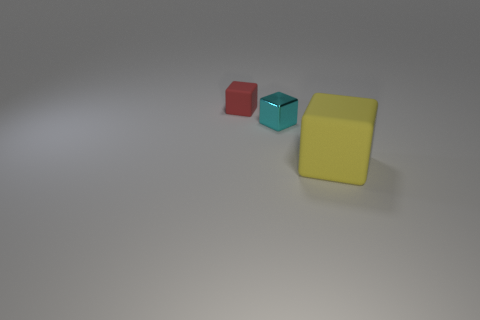Add 1 tiny shiny spheres. How many objects exist? 4 Subtract all tiny matte things. Subtract all yellow matte things. How many objects are left? 1 Add 3 cyan metal things. How many cyan metal things are left? 4 Add 3 metal things. How many metal things exist? 4 Subtract 0 gray balls. How many objects are left? 3 